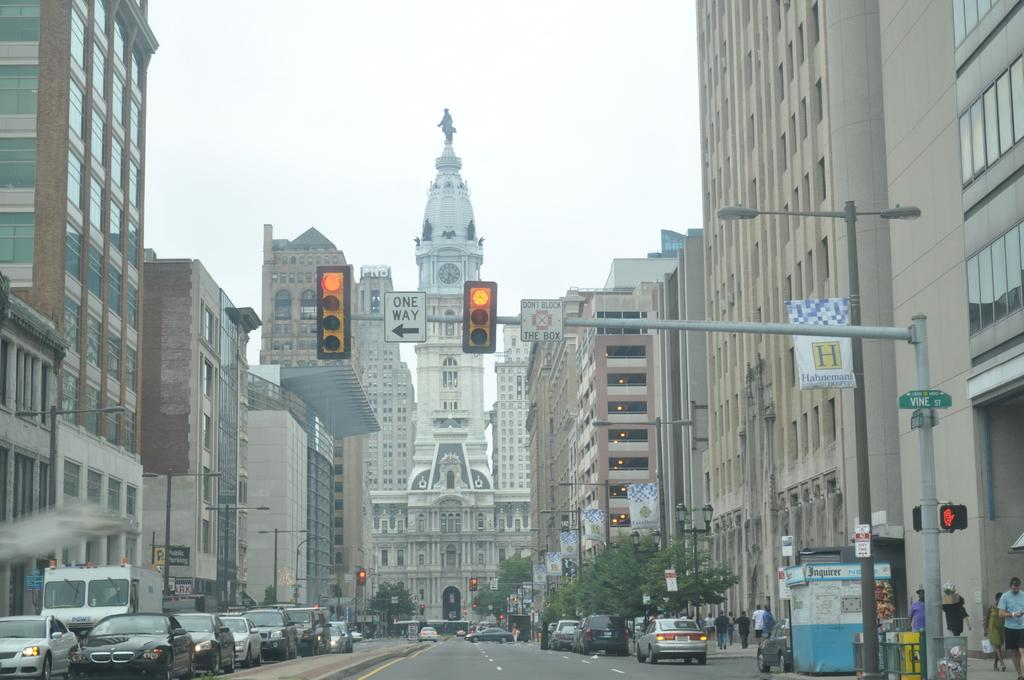<image>
Create a compact narrative representing the image presented. Two traffic lights on yellow with a one way sign between them. 